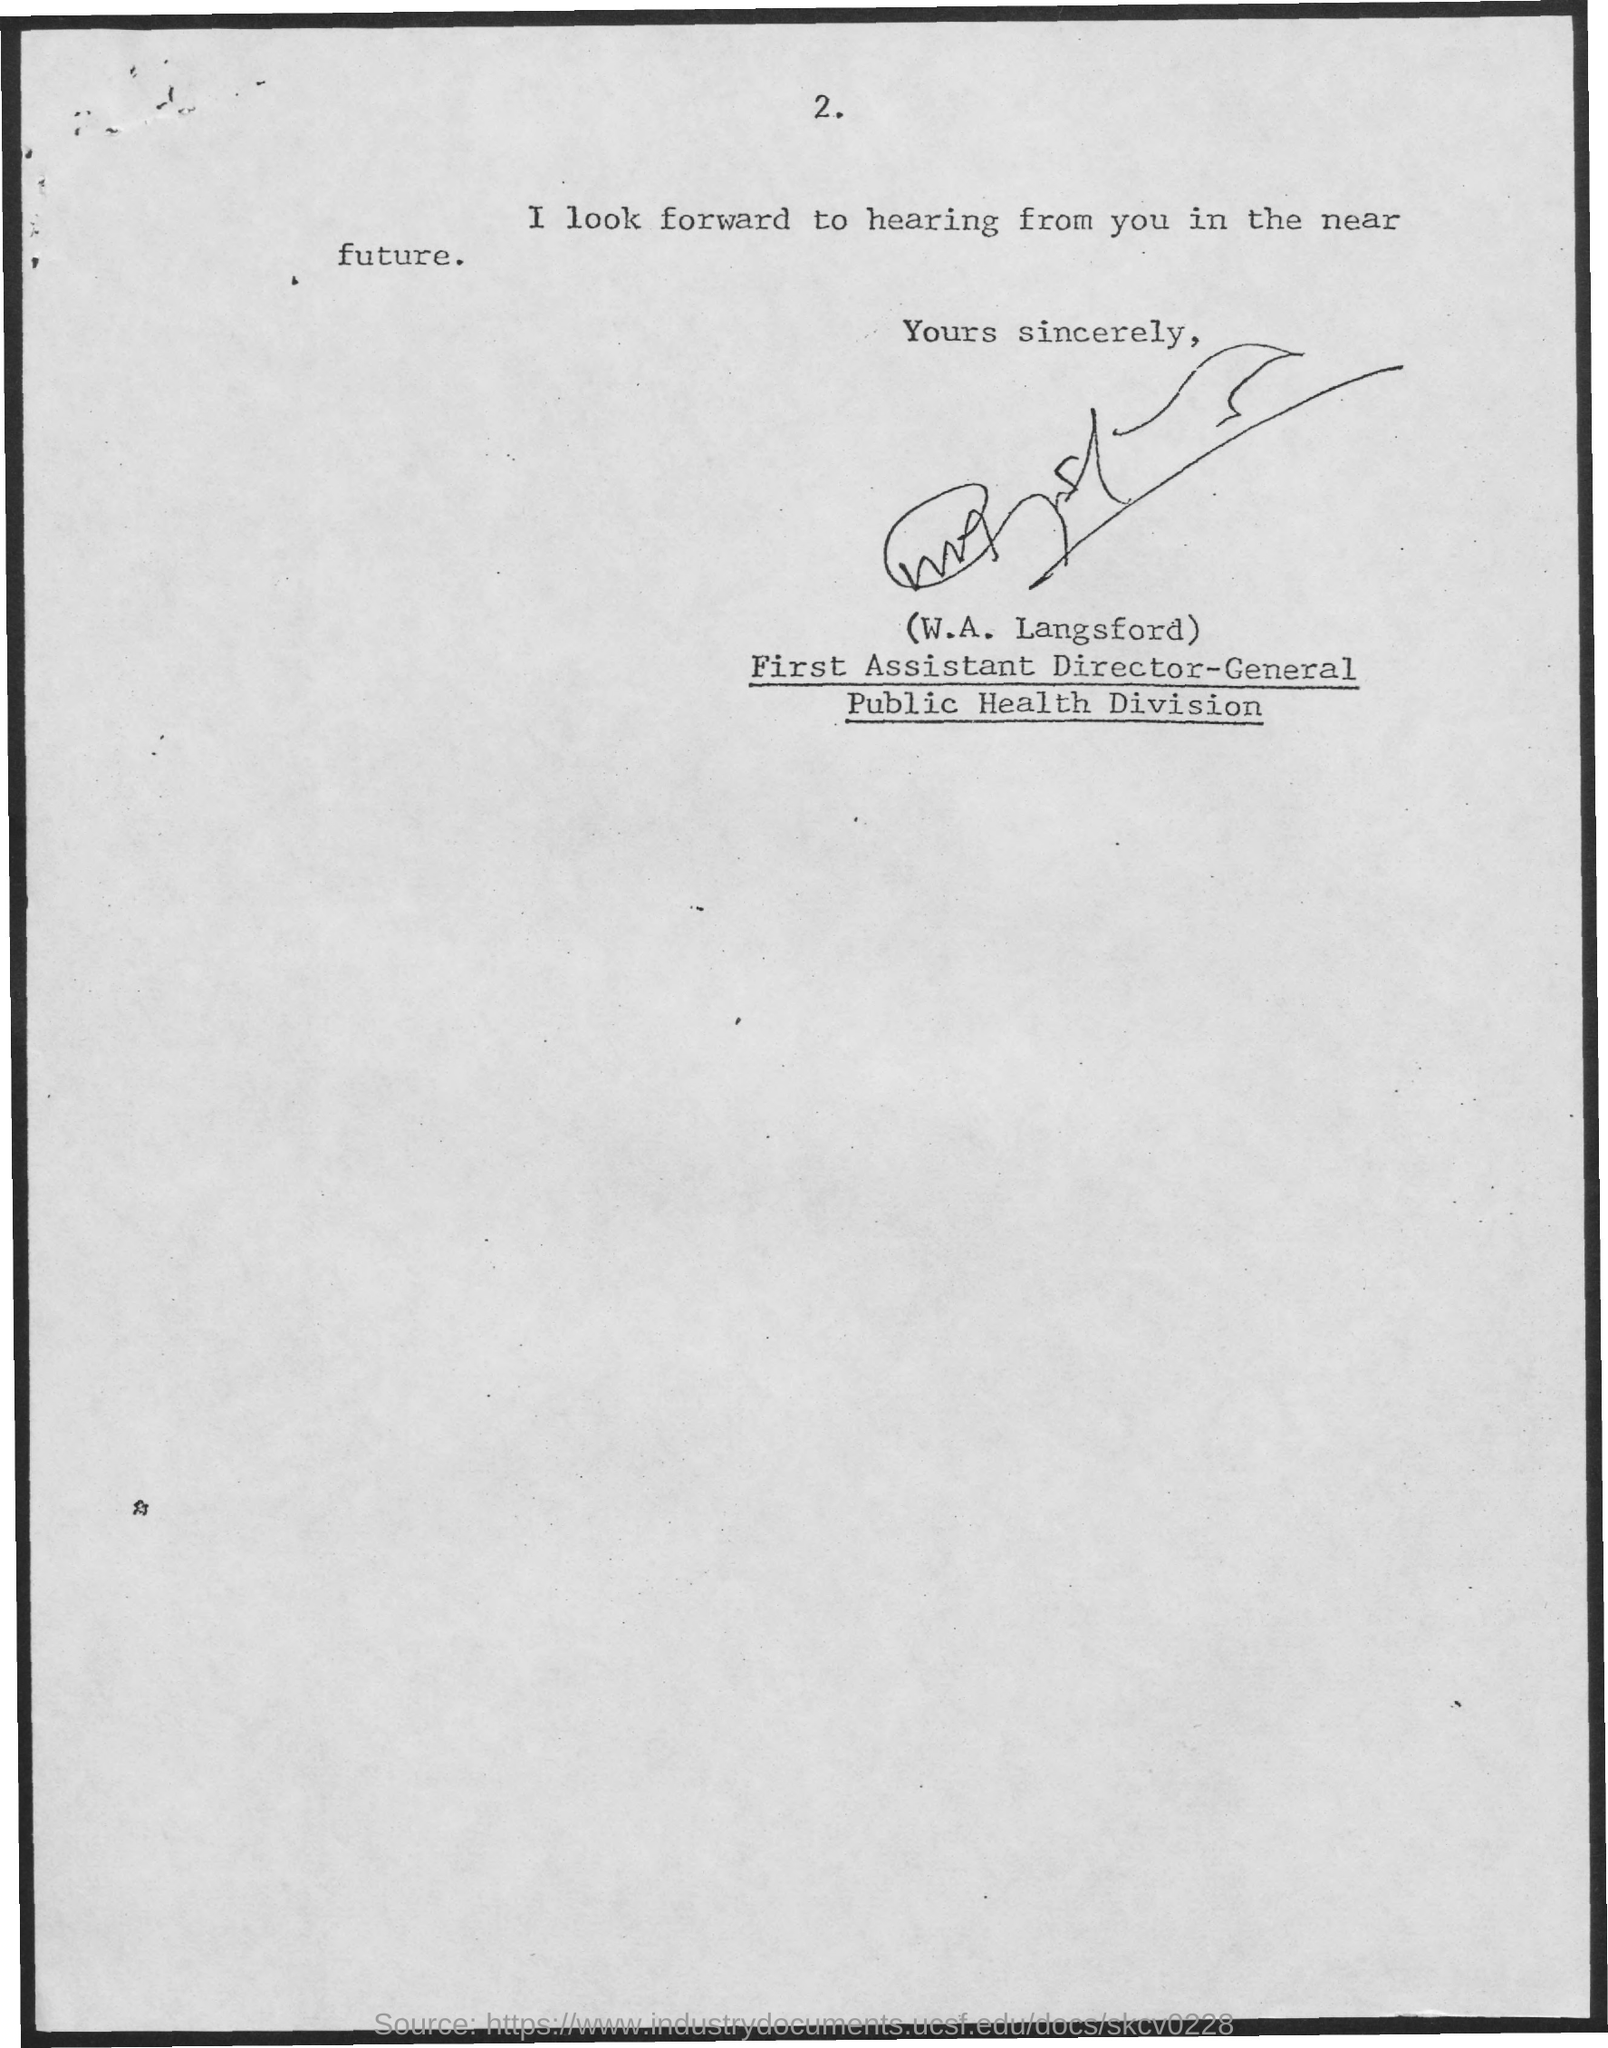What is the Page Number?
Your response must be concise. 2. Who is the First Assistant director-general in public health division?
Keep it short and to the point. W.A. Langsford. 